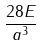Convert formula to latex. <formula><loc_0><loc_0><loc_500><loc_500>\frac { 2 8 E } { a ^ { 3 } }</formula> 